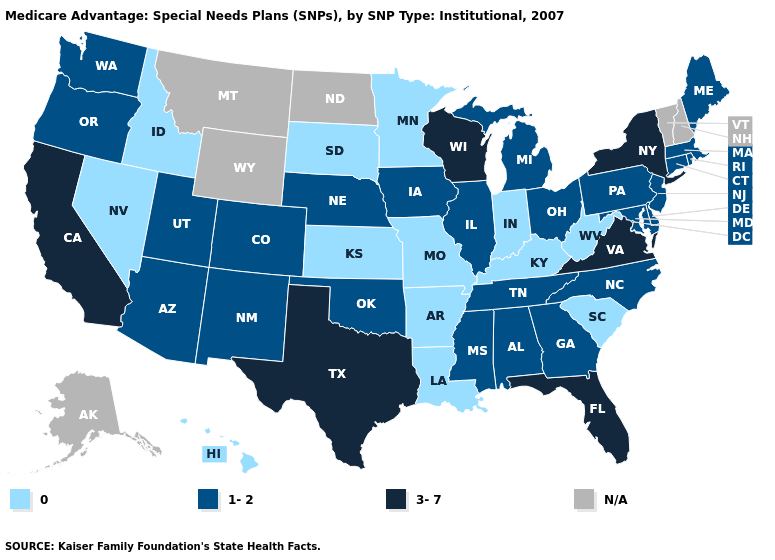Name the states that have a value in the range 1-2?
Keep it brief. Alabama, Arizona, Colorado, Connecticut, Delaware, Georgia, Iowa, Illinois, Massachusetts, Maryland, Maine, Michigan, Mississippi, North Carolina, Nebraska, New Jersey, New Mexico, Ohio, Oklahoma, Oregon, Pennsylvania, Rhode Island, Tennessee, Utah, Washington. Name the states that have a value in the range 1-2?
Answer briefly. Alabama, Arizona, Colorado, Connecticut, Delaware, Georgia, Iowa, Illinois, Massachusetts, Maryland, Maine, Michigan, Mississippi, North Carolina, Nebraska, New Jersey, New Mexico, Ohio, Oklahoma, Oregon, Pennsylvania, Rhode Island, Tennessee, Utah, Washington. Among the states that border Delaware , which have the lowest value?
Quick response, please. Maryland, New Jersey, Pennsylvania. What is the highest value in the South ?
Write a very short answer. 3-7. Does the first symbol in the legend represent the smallest category?
Quick response, please. Yes. Name the states that have a value in the range 1-2?
Quick response, please. Alabama, Arizona, Colorado, Connecticut, Delaware, Georgia, Iowa, Illinois, Massachusetts, Maryland, Maine, Michigan, Mississippi, North Carolina, Nebraska, New Jersey, New Mexico, Ohio, Oklahoma, Oregon, Pennsylvania, Rhode Island, Tennessee, Utah, Washington. Name the states that have a value in the range 1-2?
Write a very short answer. Alabama, Arizona, Colorado, Connecticut, Delaware, Georgia, Iowa, Illinois, Massachusetts, Maryland, Maine, Michigan, Mississippi, North Carolina, Nebraska, New Jersey, New Mexico, Ohio, Oklahoma, Oregon, Pennsylvania, Rhode Island, Tennessee, Utah, Washington. What is the value of Texas?
Keep it brief. 3-7. Which states have the highest value in the USA?
Quick response, please. California, Florida, New York, Texas, Virginia, Wisconsin. Name the states that have a value in the range 3-7?
Be succinct. California, Florida, New York, Texas, Virginia, Wisconsin. Name the states that have a value in the range 0?
Short answer required. Arkansas, Hawaii, Idaho, Indiana, Kansas, Kentucky, Louisiana, Minnesota, Missouri, Nevada, South Carolina, South Dakota, West Virginia. Name the states that have a value in the range 0?
Be succinct. Arkansas, Hawaii, Idaho, Indiana, Kansas, Kentucky, Louisiana, Minnesota, Missouri, Nevada, South Carolina, South Dakota, West Virginia. Name the states that have a value in the range 3-7?
Give a very brief answer. California, Florida, New York, Texas, Virginia, Wisconsin. 